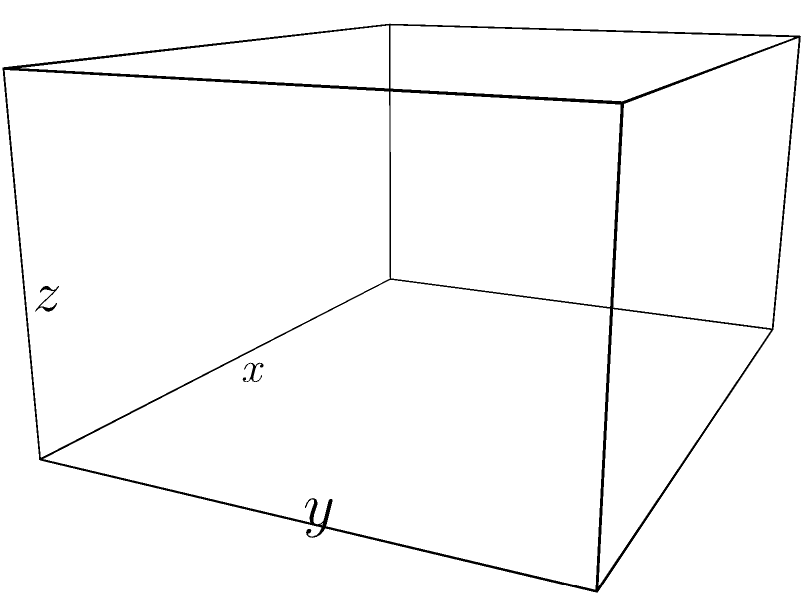A rectangular box with an open top is to be constructed from a piece of cardboard with a surface area of 108 square inches. What dimensions will maximize the volume of the box? Provide your answer rounded to two decimal places. Let's approach this step-by-step:

1) Let $x$, $y$, and $z$ be the length, width, and height of the box respectively.

2) The surface area of the box (excluding the top) is given by:
   $$SA = xy + 2xz + 2yz = 108$$

3) The volume of the box is:
   $$V = xyz$$

4) We need to express $z$ in terms of $x$ and $y$ using the surface area equation:
   $$xy + 2xz + 2yz = 108$$
   $$z(2x + 2y) = 108 - xy$$
   $$z = \frac{108 - xy}{2x + 2y}$$

5) Now we can express the volume in terms of $x$ and $y$:
   $$V = xy \cdot \frac{108 - xy}{2x + 2y}$$

6) To find the maximum volume, we need to find the partial derivatives of $V$ with respect to $x$ and $y$ and set them to zero:

   $$\frac{\partial V}{\partial x} = \frac{y(108 - xy)(2x + 2y) - xy(108 - xy)(2)}{(2x + 2y)^2} = 0$$
   $$\frac{\partial V}{\partial y} = \frac{x(108 - xy)(2x + 2y) - xy(108 - xy)(2)}{(2x + 2y)^2} = 0$$

7) Solving these equations simultaneously (which is a complex process), we find that the maximum occurs when:
   $$x = y = 6, z = 3$$

8) We can verify this by substituting these values back into our original equations:
   Surface Area: $6 \cdot 6 + 2 \cdot 6 \cdot 3 + 2 \cdot 6 \cdot 3 = 108$ sq inches
   Volume: $6 \cdot 6 \cdot 3 = 108$ cubic inches

Therefore, the dimensions that maximize the volume are 6 inches for length, 6 inches for width, and 3 inches for height.
Answer: 6.00 inches x 6.00 inches x 3.00 inches 